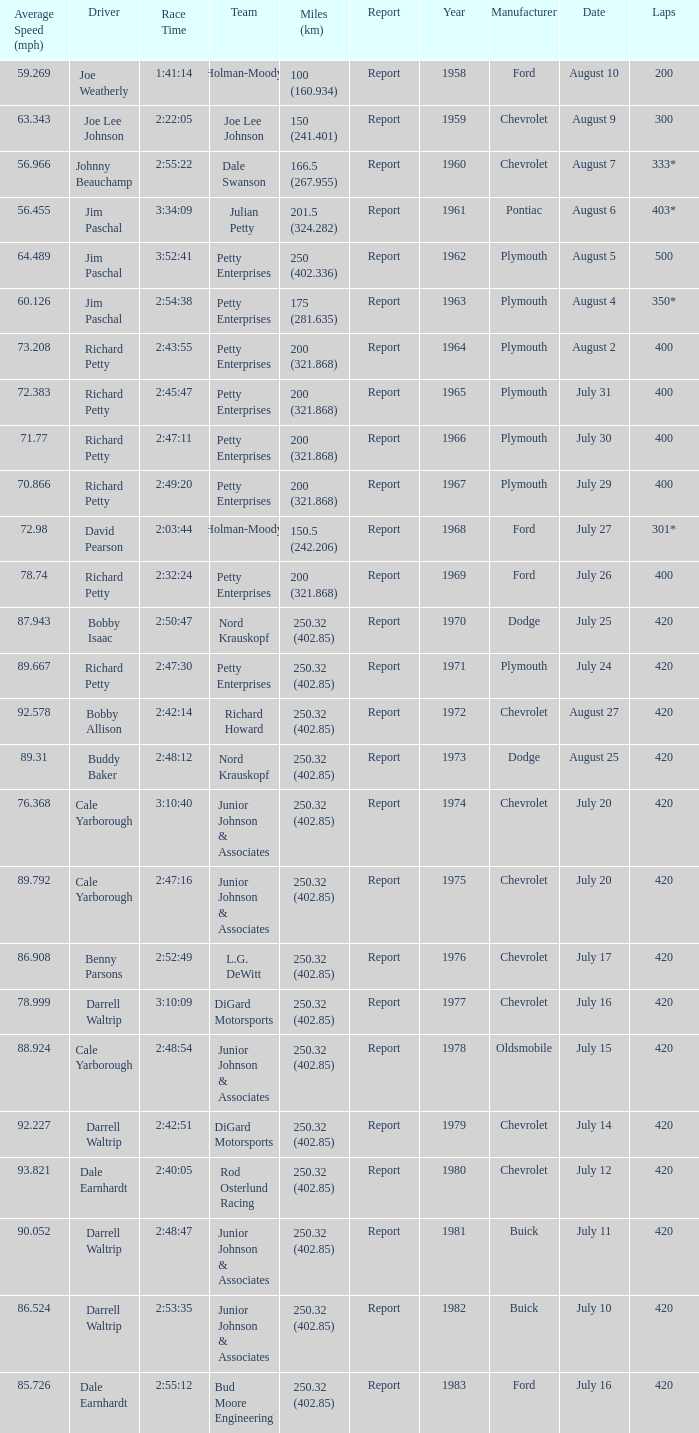What year had a race with 301* laps? 1968.0. 